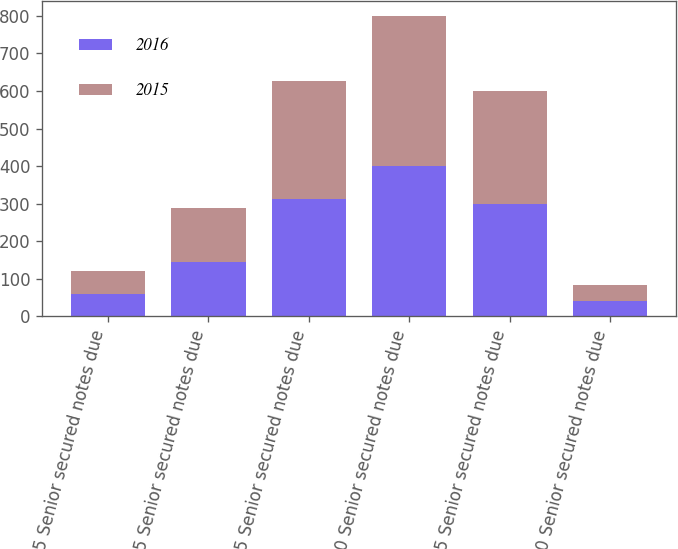<chart> <loc_0><loc_0><loc_500><loc_500><stacked_bar_chart><ecel><fcel>6125 Senior secured notes due<fcel>625 Senior secured notes due<fcel>975 Senior secured notes due<fcel>270 Senior secured notes due<fcel>325 Senior secured notes due<fcel>670 Senior secured notes due<nl><fcel>2016<fcel>60<fcel>144<fcel>313<fcel>400<fcel>300<fcel>42<nl><fcel>2015<fcel>60<fcel>144<fcel>313<fcel>400<fcel>300<fcel>42<nl></chart> 